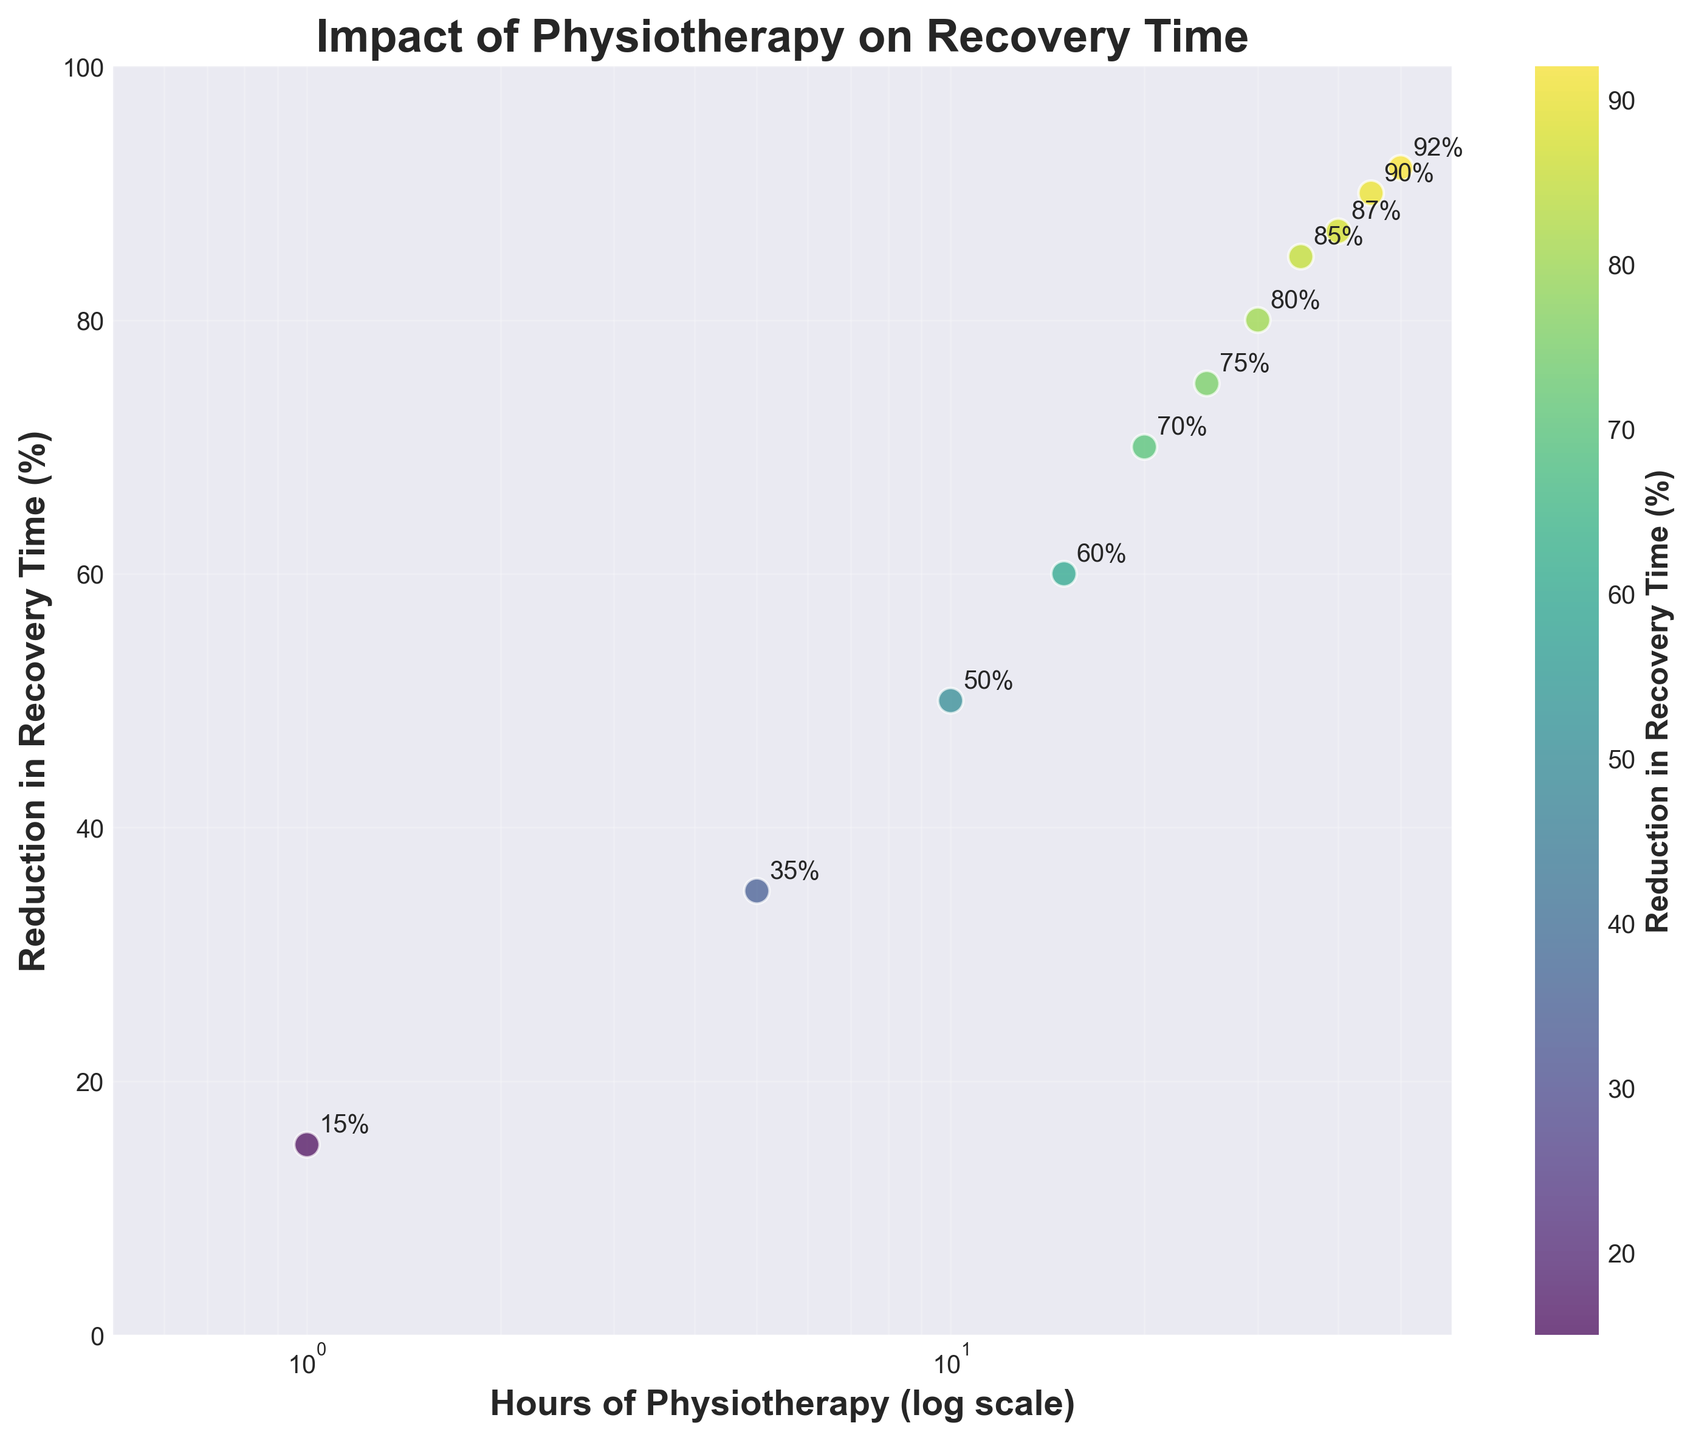What is the title of the scatter plot? The title of a visual figure is typically located at the top center. In this case, it's written in bold and directly states what the plot depicts.
Answer: Impact of Physiotherapy on Recovery Time What is the x-axis label in the scatter plot? The x-axis label is located at the bottom of the scatter plot and describes the variable represented along the horizontal axis.
Answer: Hours of Physiotherapy (log scale) How many data points are plotted on the scatter plot? By counting each individual point on the scatter plot, we can determine the number of data points shown.
Answer: 11 Which color is used for the data points in the scatter plot? By examining the color of the data points on the plot and the color bar, we can deduce the color used.
Answer: Viridis (ranging from shades of yellow to green to blue) What is the reduction in recovery time for 25 hours of physiotherapy? Locate the data point corresponding to 25 hours on the x-axis, then check the associated value on the y-axis or next to the annotation.
Answer: 75% Between which two x-values does the reduction in recovery time increase the most? By observing the steepness of the incremental changes on the y-axis and comparing them for each interval, we determine the highest difference.
Answer: Between 1 and 5 hours What is the median reduction in recovery time percentage across all data points? Arrange all y-values in ascending order: 15, 35, 50, 60, 70, 75, 80, 85, 87, 90, 92. The median is the middle value.
Answer: 75% Does the correlation between hours of physiotherapy and reduction in recovery time seem positive or negative? By observing the general trend of the points from left (low x-values) to right (high x-values), we notice the direction of the trend.
Answer: Positive At how many hours of physiotherapy does the reduction in recovery time surpass 85% for the first time? By checking the data points where y-values first exceed 85% and finding the corresponding x-value on the log scale.
Answer: 35 hours How does the reduction in recovery time change between 40 and 50 hours of physiotherapy? Observing the data points corresponding to 40 and 50 hours on the x-axis and their associated y-values, compare the differences.
Answer: It increases from 87% to 92% 